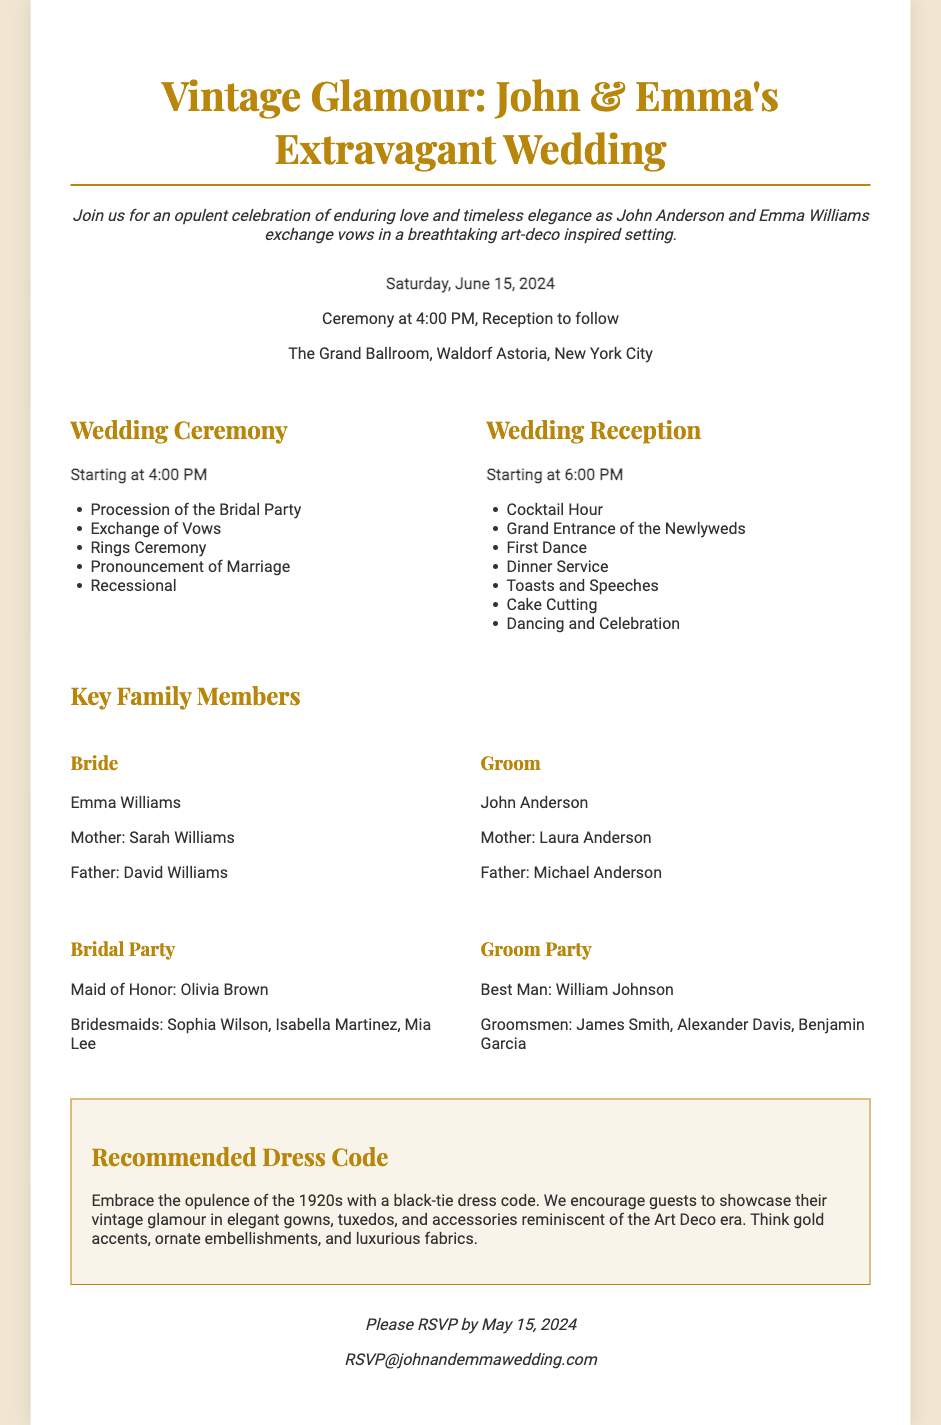What is the wedding date? The wedding date is explicitly stated in the invitation as "Saturday, June 15, 2024."
Answer: Saturday, June 15, 2024 What time does the ceremony start? The invitation specifies the start time of the ceremony as "4:00 PM."
Answer: 4:00 PM Who is the Maid of Honor? The document lists Olivia Brown as the Maid of Honor under the Bridal Party section.
Answer: Olivia Brown What is the recommended dress code? The dress code section clearly states "black-tie dress code" as the recommendation for guests.
Answer: black-tie dress code What venue is the wedding taking place at? The invitation mentions "The Grand Ballroom, Waldorf Astoria, New York City" as the venue for the wedding.
Answer: The Grand Ballroom, Waldorf Astoria, New York City How many Groomsmen are listed? Upon reviewing the Groom Party details, four groomsmen are mentioned: James Smith, Alexander Davis, and Benjamin Garcia.
Answer: 3 What is the RSVP deadline? The footer provides the RSVP deadline as "May 15, 2024."
Answer: May 15, 2024 What is the purpose of the document? The document is a wedding invitation detailing the event for John and Emma's wedding ceremony and reception.
Answer: Wedding invitation 